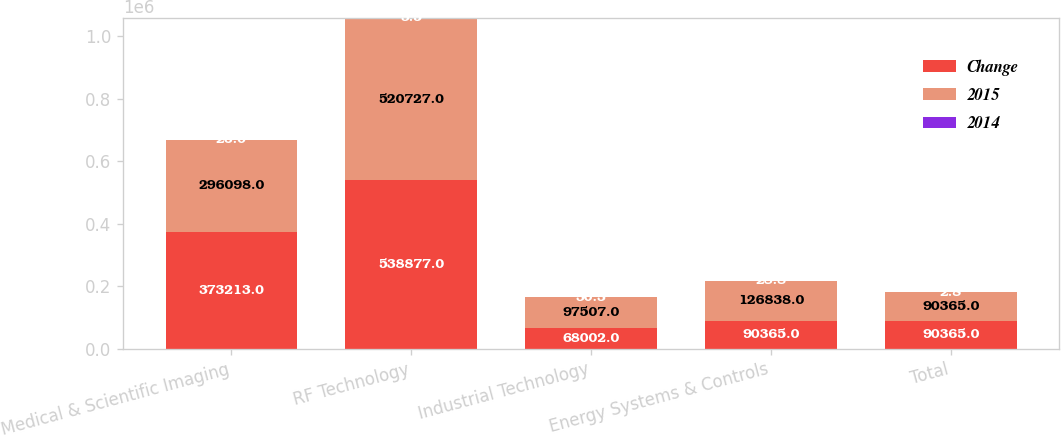Convert chart. <chart><loc_0><loc_0><loc_500><loc_500><stacked_bar_chart><ecel><fcel>Medical & Scientific Imaging<fcel>RF Technology<fcel>Industrial Technology<fcel>Energy Systems & Controls<fcel>Total<nl><fcel>Change<fcel>373213<fcel>538877<fcel>68002<fcel>90365<fcel>90365<nl><fcel>2015<fcel>296098<fcel>520727<fcel>97507<fcel>126838<fcel>90365<nl><fcel>2014<fcel>26<fcel>3.5<fcel>30.3<fcel>28.8<fcel>2.8<nl></chart> 